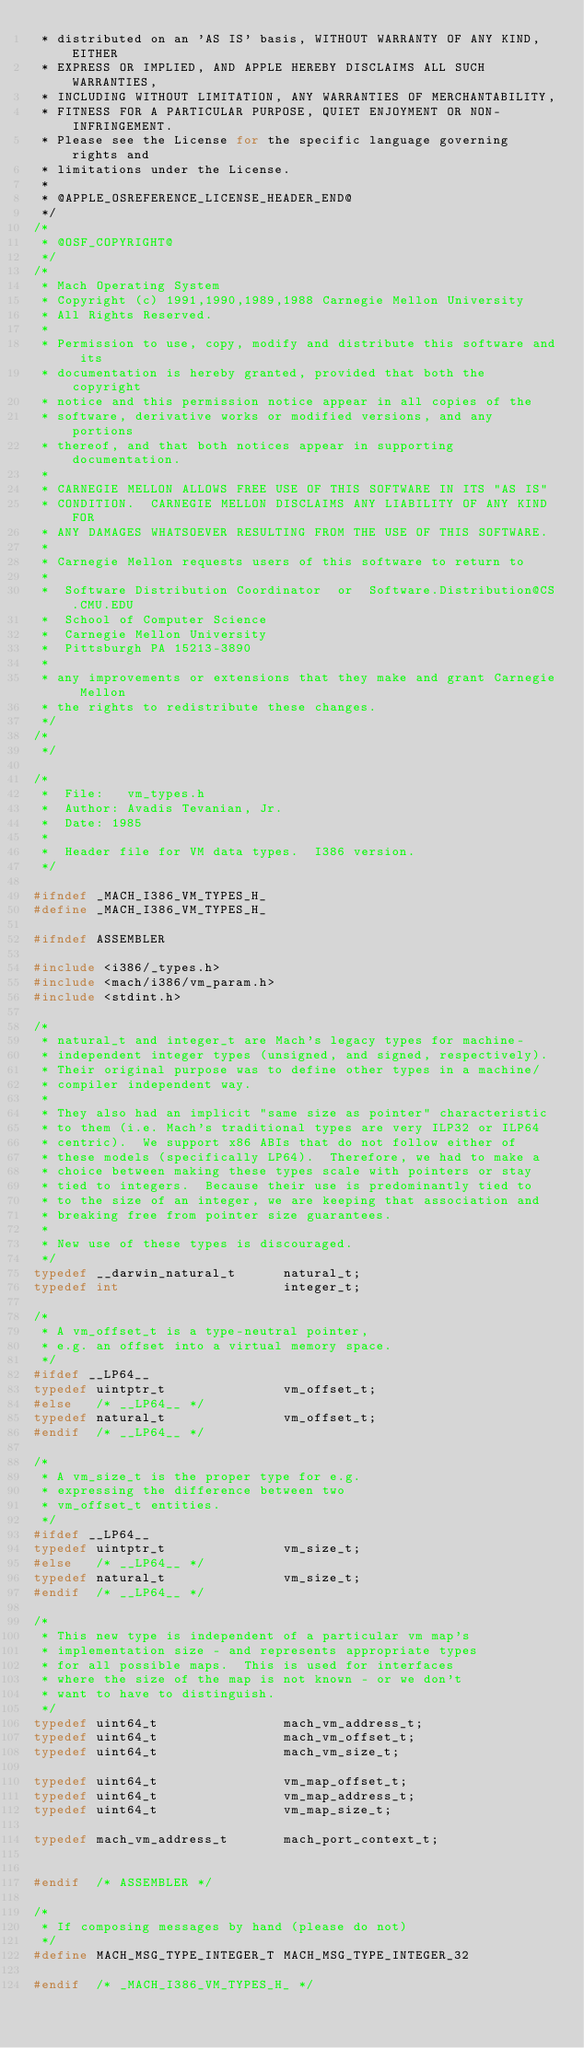Convert code to text. <code><loc_0><loc_0><loc_500><loc_500><_C_> * distributed on an 'AS IS' basis, WITHOUT WARRANTY OF ANY KIND, EITHER
 * EXPRESS OR IMPLIED, AND APPLE HEREBY DISCLAIMS ALL SUCH WARRANTIES,
 * INCLUDING WITHOUT LIMITATION, ANY WARRANTIES OF MERCHANTABILITY,
 * FITNESS FOR A PARTICULAR PURPOSE, QUIET ENJOYMENT OR NON-INFRINGEMENT.
 * Please see the License for the specific language governing rights and
 * limitations under the License.
 *
 * @APPLE_OSREFERENCE_LICENSE_HEADER_END@
 */
/*
 * @OSF_COPYRIGHT@
 */
/*
 * Mach Operating System
 * Copyright (c) 1991,1990,1989,1988 Carnegie Mellon University
 * All Rights Reserved.
 *
 * Permission to use, copy, modify and distribute this software and its
 * documentation is hereby granted, provided that both the copyright
 * notice and this permission notice appear in all copies of the
 * software, derivative works or modified versions, and any portions
 * thereof, and that both notices appear in supporting documentation.
 *
 * CARNEGIE MELLON ALLOWS FREE USE OF THIS SOFTWARE IN ITS "AS IS"
 * CONDITION.  CARNEGIE MELLON DISCLAIMS ANY LIABILITY OF ANY KIND FOR
 * ANY DAMAGES WHATSOEVER RESULTING FROM THE USE OF THIS SOFTWARE.
 *
 * Carnegie Mellon requests users of this software to return to
 *
 *  Software Distribution Coordinator  or  Software.Distribution@CS.CMU.EDU
 *  School of Computer Science
 *  Carnegie Mellon University
 *  Pittsburgh PA 15213-3890
 *
 * any improvements or extensions that they make and grant Carnegie Mellon
 * the rights to redistribute these changes.
 */
/*
 */

/*
 *	File:	vm_types.h
 *	Author:	Avadis Tevanian, Jr.
 *	Date: 1985
 *
 *	Header file for VM data types.  I386 version.
 */

#ifndef _MACH_I386_VM_TYPES_H_
#define _MACH_I386_VM_TYPES_H_

#ifndef ASSEMBLER

#include <i386/_types.h>
#include <mach/i386/vm_param.h>
#include <stdint.h>

/*
 * natural_t and integer_t are Mach's legacy types for machine-
 * independent integer types (unsigned, and signed, respectively).
 * Their original purpose was to define other types in a machine/
 * compiler independent way.
 *
 * They also had an implicit "same size as pointer" characteristic
 * to them (i.e. Mach's traditional types are very ILP32 or ILP64
 * centric).  We support x86 ABIs that do not follow either of
 * these models (specifically LP64).  Therefore, we had to make a
 * choice between making these types scale with pointers or stay
 * tied to integers.  Because their use is predominantly tied to
 * to the size of an integer, we are keeping that association and
 * breaking free from pointer size guarantees.
 *
 * New use of these types is discouraged.
 */
typedef __darwin_natural_t      natural_t;
typedef int                     integer_t;

/*
 * A vm_offset_t is a type-neutral pointer,
 * e.g. an offset into a virtual memory space.
 */
#ifdef __LP64__
typedef uintptr_t               vm_offset_t;
#else   /* __LP64__ */
typedef natural_t               vm_offset_t;
#endif  /* __LP64__ */

/*
 * A vm_size_t is the proper type for e.g.
 * expressing the difference between two
 * vm_offset_t entities.
 */
#ifdef __LP64__
typedef uintptr_t               vm_size_t;
#else   /* __LP64__ */
typedef natural_t               vm_size_t;
#endif  /* __LP64__ */

/*
 * This new type is independent of a particular vm map's
 * implementation size - and represents appropriate types
 * for all possible maps.  This is used for interfaces
 * where the size of the map is not known - or we don't
 * want to have to distinguish.
 */
typedef uint64_t                mach_vm_address_t;
typedef uint64_t                mach_vm_offset_t;
typedef uint64_t                mach_vm_size_t;

typedef uint64_t                vm_map_offset_t;
typedef uint64_t                vm_map_address_t;
typedef uint64_t                vm_map_size_t;

typedef mach_vm_address_t       mach_port_context_t;


#endif  /* ASSEMBLER */

/*
 * If composing messages by hand (please do not)
 */
#define MACH_MSG_TYPE_INTEGER_T MACH_MSG_TYPE_INTEGER_32

#endif  /* _MACH_I386_VM_TYPES_H_ */
</code> 